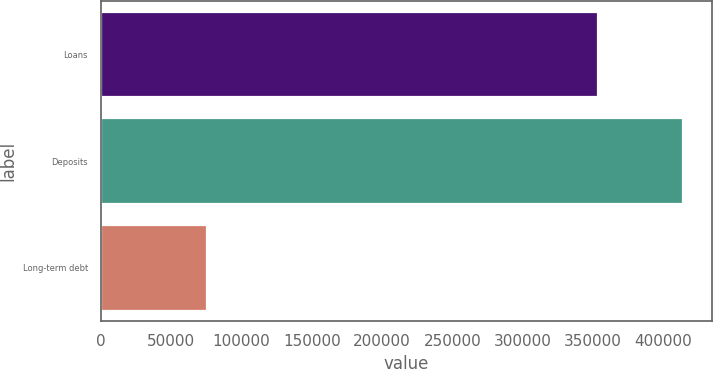<chart> <loc_0><loc_0><loc_500><loc_500><bar_chart><fcel>Loans<fcel>Deposits<fcel>Long-term debt<nl><fcel>353924<fcel>414113<fcel>75343<nl></chart> 